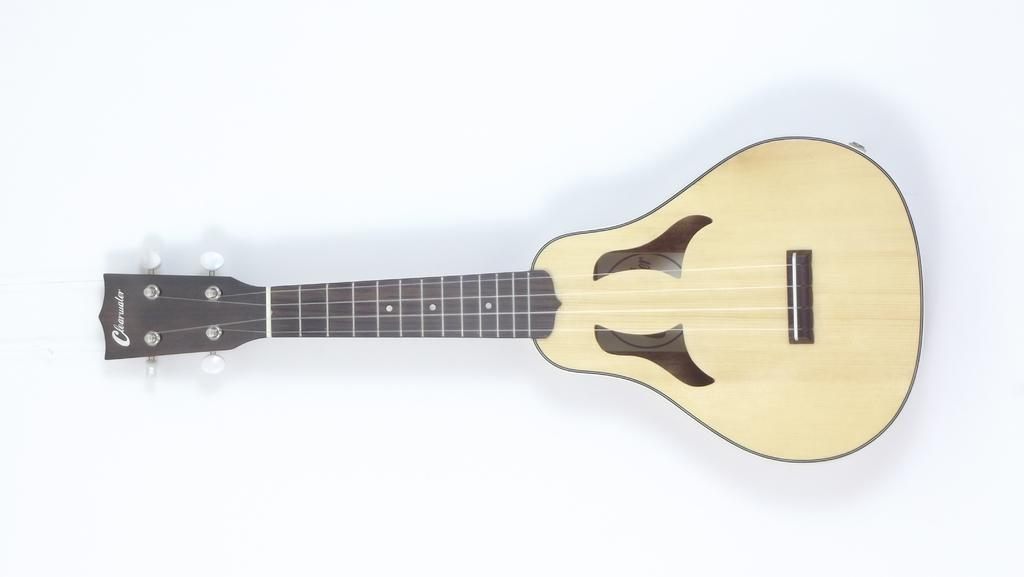What musical instrument is present in the image? There is a guitar in the image. Where is the guitar placed in the image? The guitar is on a surface in the image. What color is the background of the image? The background of the image is white in color. What scientific discovery was made during the guitar's creation? There is no information about the guitar's creation or any scientific discoveries in the image. 